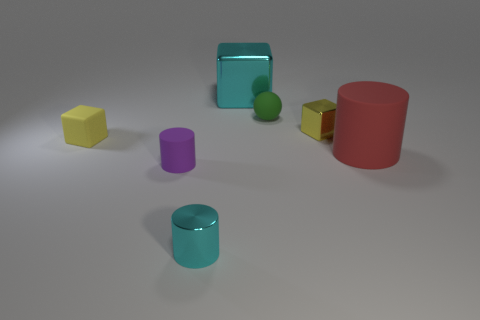Add 2 big cyan objects. How many objects exist? 9 Subtract all balls. How many objects are left? 6 Add 4 tiny purple rubber cylinders. How many tiny purple rubber cylinders are left? 5 Add 6 big gray spheres. How many big gray spheres exist? 6 Subtract 0 blue spheres. How many objects are left? 7 Subtract all small purple cylinders. Subtract all balls. How many objects are left? 5 